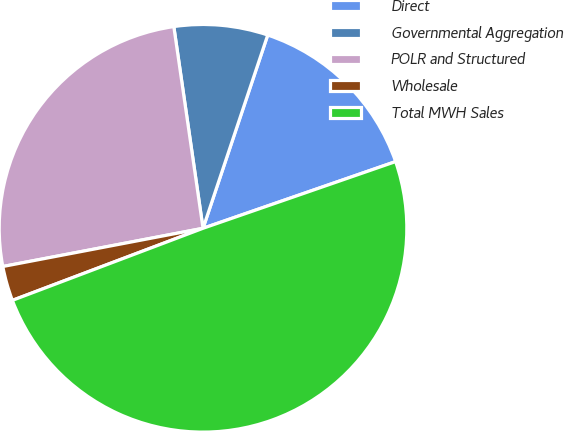Convert chart to OTSL. <chart><loc_0><loc_0><loc_500><loc_500><pie_chart><fcel>Direct<fcel>Governmental Aggregation<fcel>POLR and Structured<fcel>Wholesale<fcel>Total MWH Sales<nl><fcel>14.55%<fcel>7.43%<fcel>25.71%<fcel>2.75%<fcel>49.55%<nl></chart> 